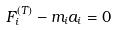<formula> <loc_0><loc_0><loc_500><loc_500>F _ { i } ^ { ( T ) } - m _ { i } a _ { i } = 0</formula> 